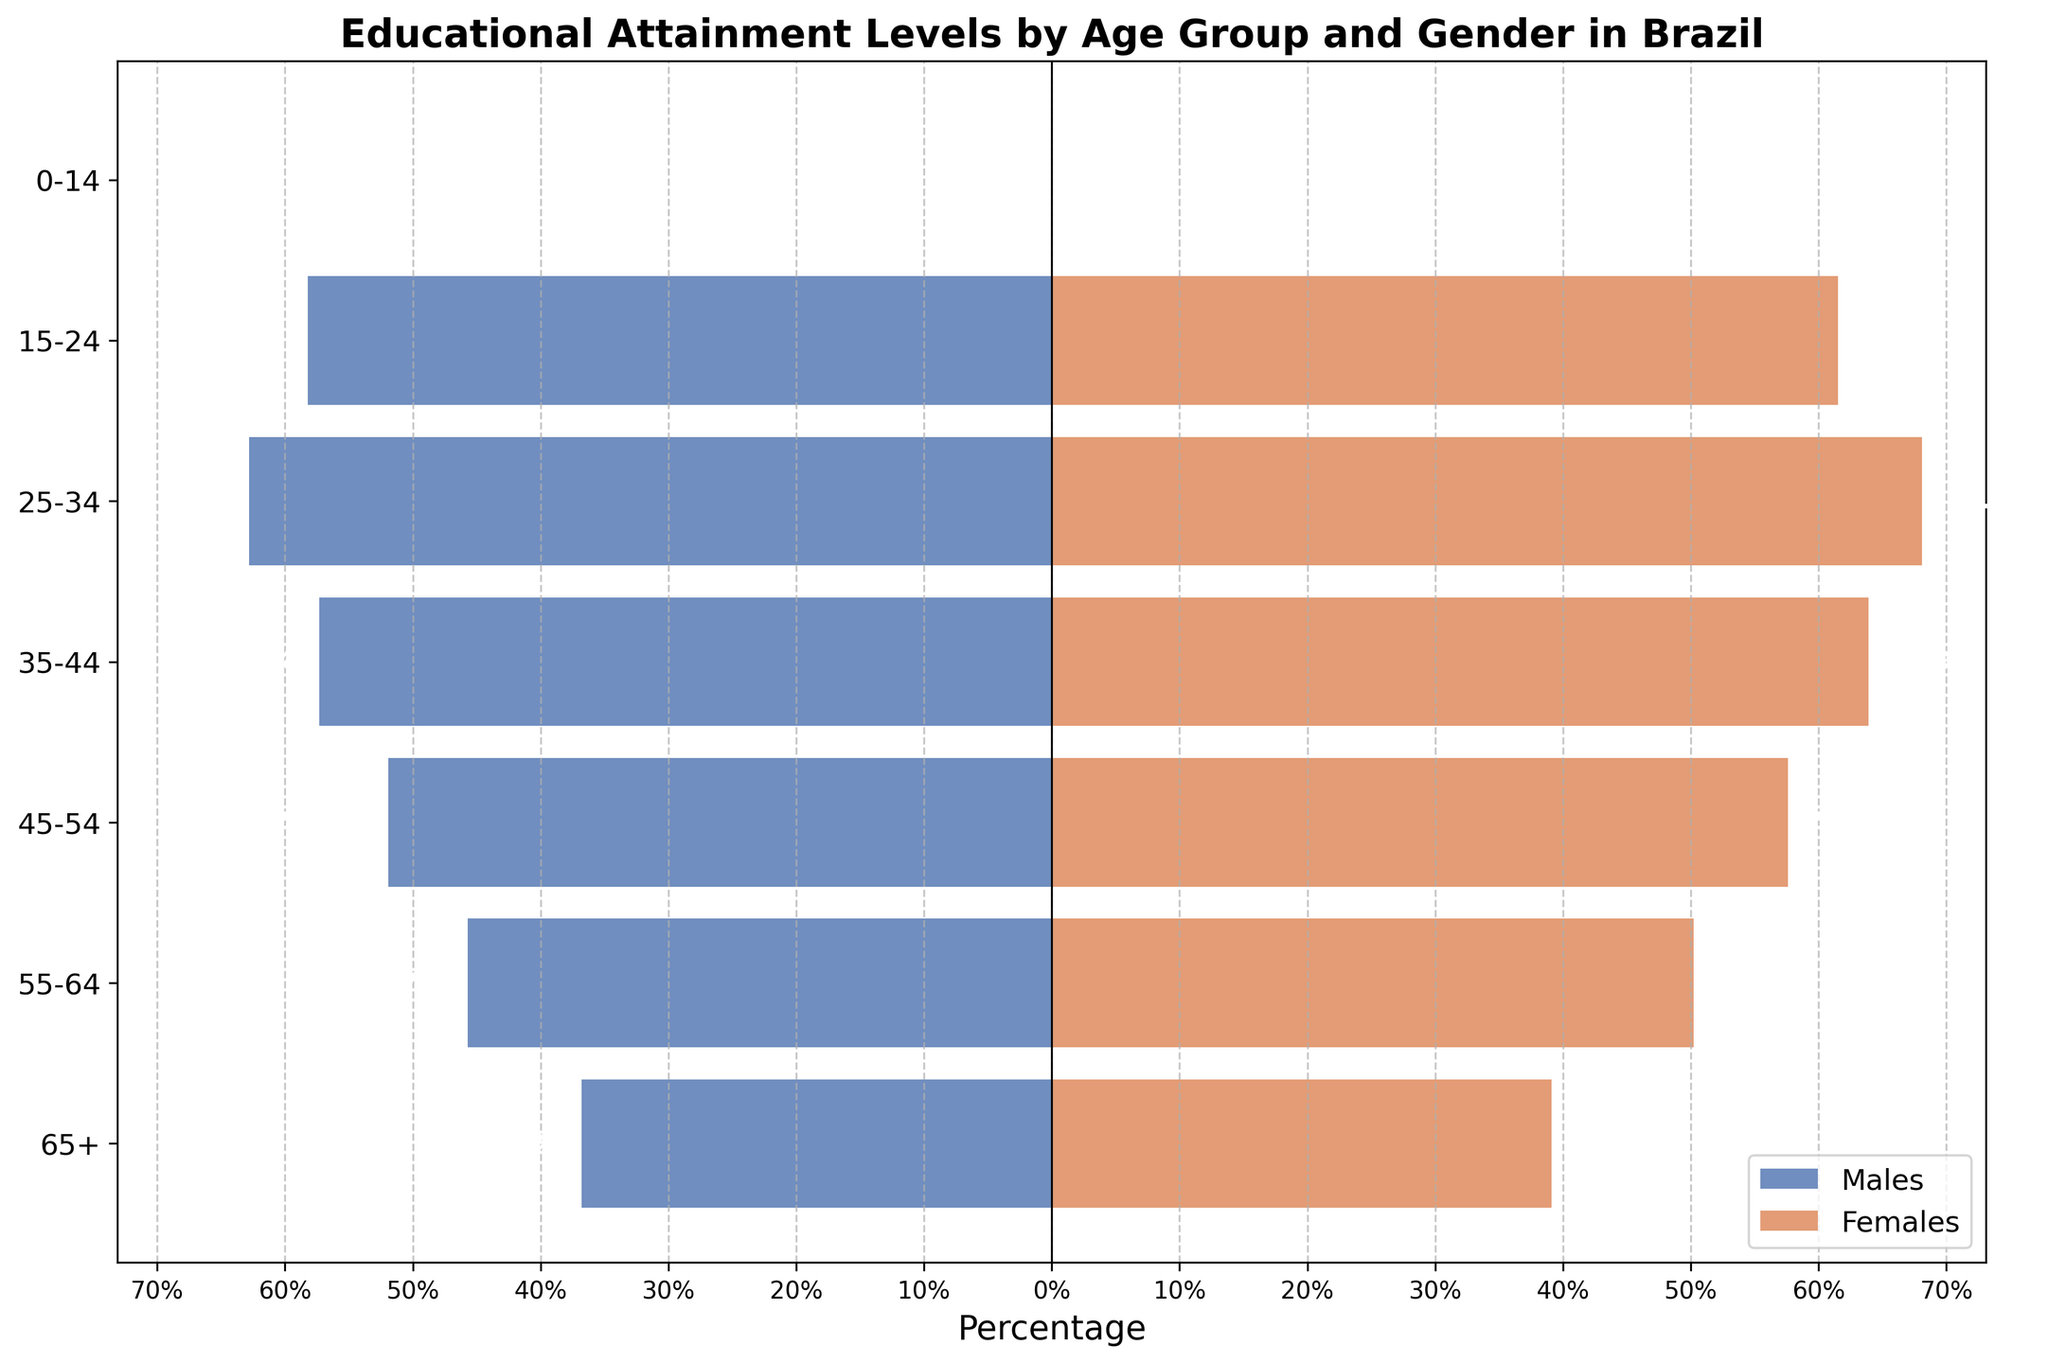What is the title of the plot? The title of the plot is typically placed at the top of the figure and is written in bold. It provides a summary of what the plot is about. Here, the title is "Educational Attainment Levels by Age Group and Gender in Brazil."
Answer: Educational Attainment Levels by Age Group and Gender in Brazil What does the color coding in the plot represent? The color coding in the plot is used to distinguish between the data for males and females. Blue bars represent males and orange bars represent females, as stated in the legend at the bottom right of the figure.
Answer: Blue for males, orange for females Which age group has the highest percentage of females with educational attainment? To identify the age group with the highest percentage of females, look at the top side of the pyramid where the orange bars are the longest. The age group with the longest orange bar is 25-34.
Answer: 25-34 What is the difference in educational attainment percentages between males and females in the 55-64 age group? To find the difference, take the absolute value of the percentages for males and females in the 55-64 age group. Subtract the males' percentage (45.7) from the females' percentage (50.2).
Answer: 4.5% In which age group is the gender gap in educational attainment the smallest? The gender gap is smallest where the difference between the lengths of the blue and orange bars is the least. Compare the differences for each age group and identify the smallest one. The smallest gap is in the 65+ age group (39.1 - 36.8).
Answer: 65+ At what age group do males have the highest educational attainment percentage? For males, find the age group with the longest blue bar on the horizontal axis. The age group with the highest percentage for males is 25-34 (58.2%).
Answer: 25-34 How much larger is the percentage of educational attainment for females compared to males in the 25-34 age group? Subtract the percentage of males (62.8) from the percentage of females (68.1) to find how much larger the females' percentage is.
Answer: 5.3% How does the educational attainment of males compare to females in the 35-44 age group? Compare the length of the blue and orange bars for the 35-44 age group. The percentage for males is 57.3 and for females is 63.9, indicating that females have a higher attainment.
Answer: Females have higher attainment What can you infer about the trend of educational attainment for both genders as age increases? Observe the overall direction and length of bars for both males and females across successive age groups. Both males and females show a decreasing trend in educational attainment percentages as age increases, indicating younger generations have higher educational attainment.
Answer: Decreasing trend for both Is there an age group where males and females have exactly the same educational attainment percentage? Check all age groups to see if there is any pair of equal-length blue and orange bars. There is no age group where males and females have exactly the same percentage.
Answer: No 